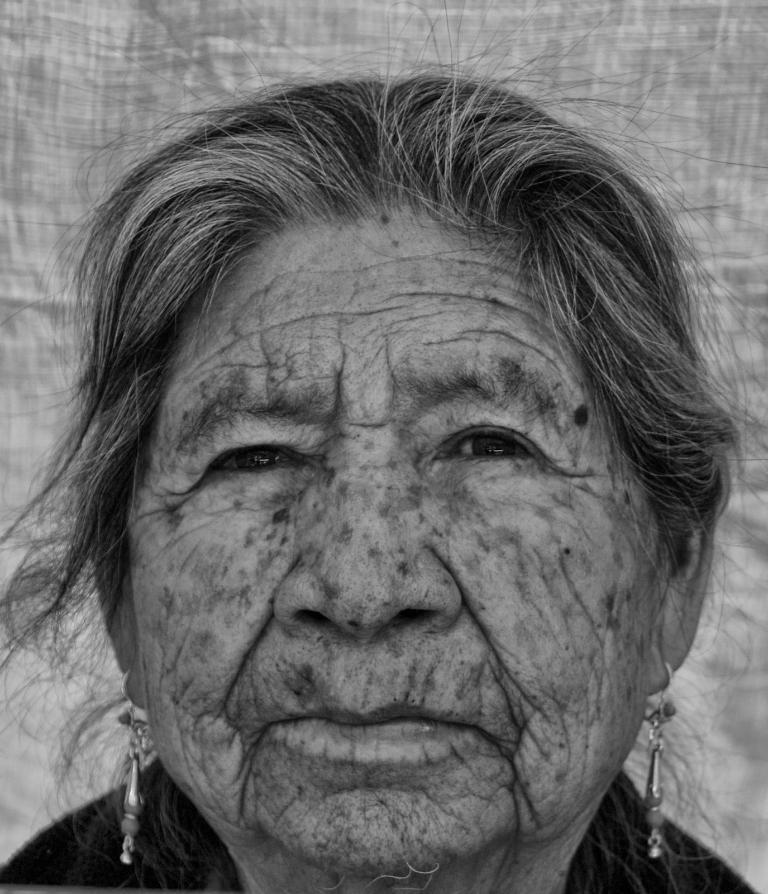In one or two sentences, can you explain what this image depicts? This is the black and white picture of a woman with earrings and behind her there is a cloth. 